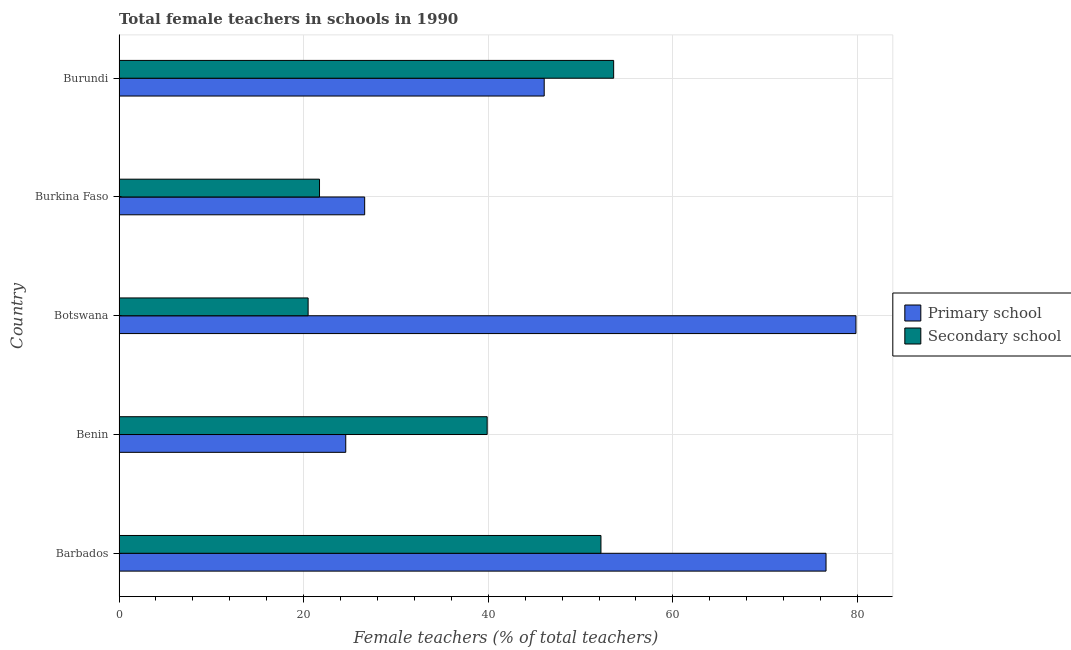How many different coloured bars are there?
Give a very brief answer. 2. How many groups of bars are there?
Your response must be concise. 5. Are the number of bars on each tick of the Y-axis equal?
Provide a succinct answer. Yes. What is the label of the 3rd group of bars from the top?
Ensure brevity in your answer.  Botswana. What is the percentage of female teachers in secondary schools in Burkina Faso?
Your answer should be very brief. 21.72. Across all countries, what is the maximum percentage of female teachers in secondary schools?
Keep it short and to the point. 53.58. Across all countries, what is the minimum percentage of female teachers in primary schools?
Offer a terse response. 24.56. In which country was the percentage of female teachers in primary schools maximum?
Offer a very short reply. Botswana. In which country was the percentage of female teachers in primary schools minimum?
Keep it short and to the point. Benin. What is the total percentage of female teachers in secondary schools in the graph?
Keep it short and to the point. 187.87. What is the difference between the percentage of female teachers in secondary schools in Benin and that in Burkina Faso?
Your response must be concise. 18.16. What is the difference between the percentage of female teachers in secondary schools in Burundi and the percentage of female teachers in primary schools in Barbados?
Your response must be concise. -23.01. What is the average percentage of female teachers in secondary schools per country?
Provide a short and direct response. 37.58. What is the difference between the percentage of female teachers in secondary schools and percentage of female teachers in primary schools in Benin?
Your answer should be compact. 15.32. In how many countries, is the percentage of female teachers in primary schools greater than 44 %?
Your answer should be compact. 3. Is the percentage of female teachers in secondary schools in Botswana less than that in Burkina Faso?
Provide a succinct answer. Yes. What is the difference between the highest and the second highest percentage of female teachers in primary schools?
Your response must be concise. 3.24. What is the difference between the highest and the lowest percentage of female teachers in secondary schools?
Provide a short and direct response. 33.1. In how many countries, is the percentage of female teachers in primary schools greater than the average percentage of female teachers in primary schools taken over all countries?
Offer a very short reply. 2. What does the 1st bar from the top in Burkina Faso represents?
Your answer should be very brief. Secondary school. What does the 1st bar from the bottom in Botswana represents?
Offer a terse response. Primary school. Are all the bars in the graph horizontal?
Ensure brevity in your answer.  Yes. How many countries are there in the graph?
Your response must be concise. 5. Are the values on the major ticks of X-axis written in scientific E-notation?
Make the answer very short. No. How are the legend labels stacked?
Offer a terse response. Vertical. What is the title of the graph?
Your answer should be compact. Total female teachers in schools in 1990. Does "Male labor force" appear as one of the legend labels in the graph?
Ensure brevity in your answer.  No. What is the label or title of the X-axis?
Your answer should be compact. Female teachers (% of total teachers). What is the Female teachers (% of total teachers) in Primary school in Barbados?
Keep it short and to the point. 76.59. What is the Female teachers (% of total teachers) of Secondary school in Barbados?
Offer a very short reply. 52.21. What is the Female teachers (% of total teachers) in Primary school in Benin?
Provide a short and direct response. 24.56. What is the Female teachers (% of total teachers) in Secondary school in Benin?
Keep it short and to the point. 39.88. What is the Female teachers (% of total teachers) in Primary school in Botswana?
Keep it short and to the point. 79.83. What is the Female teachers (% of total teachers) in Secondary school in Botswana?
Offer a very short reply. 20.48. What is the Female teachers (% of total teachers) in Primary school in Burkina Faso?
Keep it short and to the point. 26.61. What is the Female teachers (% of total teachers) of Secondary school in Burkina Faso?
Provide a short and direct response. 21.72. What is the Female teachers (% of total teachers) in Primary school in Burundi?
Keep it short and to the point. 46.06. What is the Female teachers (% of total teachers) of Secondary school in Burundi?
Make the answer very short. 53.58. Across all countries, what is the maximum Female teachers (% of total teachers) in Primary school?
Your response must be concise. 79.83. Across all countries, what is the maximum Female teachers (% of total teachers) of Secondary school?
Provide a succinct answer. 53.58. Across all countries, what is the minimum Female teachers (% of total teachers) in Primary school?
Provide a short and direct response. 24.56. Across all countries, what is the minimum Female teachers (% of total teachers) of Secondary school?
Make the answer very short. 20.48. What is the total Female teachers (% of total teachers) in Primary school in the graph?
Your answer should be compact. 253.66. What is the total Female teachers (% of total teachers) in Secondary school in the graph?
Ensure brevity in your answer.  187.87. What is the difference between the Female teachers (% of total teachers) in Primary school in Barbados and that in Benin?
Give a very brief answer. 52.03. What is the difference between the Female teachers (% of total teachers) in Secondary school in Barbados and that in Benin?
Offer a very short reply. 12.33. What is the difference between the Female teachers (% of total teachers) of Primary school in Barbados and that in Botswana?
Provide a succinct answer. -3.24. What is the difference between the Female teachers (% of total teachers) of Secondary school in Barbados and that in Botswana?
Your answer should be very brief. 31.72. What is the difference between the Female teachers (% of total teachers) of Primary school in Barbados and that in Burkina Faso?
Offer a terse response. 49.98. What is the difference between the Female teachers (% of total teachers) of Secondary school in Barbados and that in Burkina Faso?
Offer a terse response. 30.49. What is the difference between the Female teachers (% of total teachers) of Primary school in Barbados and that in Burundi?
Your answer should be compact. 30.53. What is the difference between the Female teachers (% of total teachers) in Secondary school in Barbados and that in Burundi?
Provide a succinct answer. -1.38. What is the difference between the Female teachers (% of total teachers) of Primary school in Benin and that in Botswana?
Ensure brevity in your answer.  -55.27. What is the difference between the Female teachers (% of total teachers) of Secondary school in Benin and that in Botswana?
Provide a short and direct response. 19.4. What is the difference between the Female teachers (% of total teachers) in Primary school in Benin and that in Burkina Faso?
Your response must be concise. -2.05. What is the difference between the Female teachers (% of total teachers) of Secondary school in Benin and that in Burkina Faso?
Your answer should be very brief. 18.16. What is the difference between the Female teachers (% of total teachers) in Primary school in Benin and that in Burundi?
Offer a very short reply. -21.5. What is the difference between the Female teachers (% of total teachers) in Secondary school in Benin and that in Burundi?
Keep it short and to the point. -13.7. What is the difference between the Female teachers (% of total teachers) in Primary school in Botswana and that in Burkina Faso?
Give a very brief answer. 53.22. What is the difference between the Female teachers (% of total teachers) in Secondary school in Botswana and that in Burkina Faso?
Give a very brief answer. -1.24. What is the difference between the Female teachers (% of total teachers) in Primary school in Botswana and that in Burundi?
Give a very brief answer. 33.77. What is the difference between the Female teachers (% of total teachers) of Secondary school in Botswana and that in Burundi?
Your response must be concise. -33.1. What is the difference between the Female teachers (% of total teachers) of Primary school in Burkina Faso and that in Burundi?
Provide a short and direct response. -19.45. What is the difference between the Female teachers (% of total teachers) in Secondary school in Burkina Faso and that in Burundi?
Your response must be concise. -31.87. What is the difference between the Female teachers (% of total teachers) in Primary school in Barbados and the Female teachers (% of total teachers) in Secondary school in Benin?
Make the answer very short. 36.71. What is the difference between the Female teachers (% of total teachers) in Primary school in Barbados and the Female teachers (% of total teachers) in Secondary school in Botswana?
Provide a short and direct response. 56.11. What is the difference between the Female teachers (% of total teachers) of Primary school in Barbados and the Female teachers (% of total teachers) of Secondary school in Burkina Faso?
Keep it short and to the point. 54.87. What is the difference between the Female teachers (% of total teachers) in Primary school in Barbados and the Female teachers (% of total teachers) in Secondary school in Burundi?
Your response must be concise. 23.01. What is the difference between the Female teachers (% of total teachers) in Primary school in Benin and the Female teachers (% of total teachers) in Secondary school in Botswana?
Your answer should be very brief. 4.08. What is the difference between the Female teachers (% of total teachers) of Primary school in Benin and the Female teachers (% of total teachers) of Secondary school in Burkina Faso?
Offer a very short reply. 2.84. What is the difference between the Female teachers (% of total teachers) of Primary school in Benin and the Female teachers (% of total teachers) of Secondary school in Burundi?
Give a very brief answer. -29.02. What is the difference between the Female teachers (% of total teachers) of Primary school in Botswana and the Female teachers (% of total teachers) of Secondary school in Burkina Faso?
Your response must be concise. 58.12. What is the difference between the Female teachers (% of total teachers) in Primary school in Botswana and the Female teachers (% of total teachers) in Secondary school in Burundi?
Make the answer very short. 26.25. What is the difference between the Female teachers (% of total teachers) in Primary school in Burkina Faso and the Female teachers (% of total teachers) in Secondary school in Burundi?
Make the answer very short. -26.97. What is the average Female teachers (% of total teachers) of Primary school per country?
Ensure brevity in your answer.  50.73. What is the average Female teachers (% of total teachers) in Secondary school per country?
Provide a succinct answer. 37.57. What is the difference between the Female teachers (% of total teachers) in Primary school and Female teachers (% of total teachers) in Secondary school in Barbados?
Your answer should be very brief. 24.38. What is the difference between the Female teachers (% of total teachers) in Primary school and Female teachers (% of total teachers) in Secondary school in Benin?
Your answer should be very brief. -15.32. What is the difference between the Female teachers (% of total teachers) in Primary school and Female teachers (% of total teachers) in Secondary school in Botswana?
Offer a terse response. 59.35. What is the difference between the Female teachers (% of total teachers) of Primary school and Female teachers (% of total teachers) of Secondary school in Burkina Faso?
Ensure brevity in your answer.  4.89. What is the difference between the Female teachers (% of total teachers) in Primary school and Female teachers (% of total teachers) in Secondary school in Burundi?
Make the answer very short. -7.52. What is the ratio of the Female teachers (% of total teachers) of Primary school in Barbados to that in Benin?
Offer a very short reply. 3.12. What is the ratio of the Female teachers (% of total teachers) in Secondary school in Barbados to that in Benin?
Provide a short and direct response. 1.31. What is the ratio of the Female teachers (% of total teachers) of Primary school in Barbados to that in Botswana?
Your answer should be compact. 0.96. What is the ratio of the Female teachers (% of total teachers) in Secondary school in Barbados to that in Botswana?
Your response must be concise. 2.55. What is the ratio of the Female teachers (% of total teachers) of Primary school in Barbados to that in Burkina Faso?
Ensure brevity in your answer.  2.88. What is the ratio of the Female teachers (% of total teachers) in Secondary school in Barbados to that in Burkina Faso?
Offer a very short reply. 2.4. What is the ratio of the Female teachers (% of total teachers) of Primary school in Barbados to that in Burundi?
Keep it short and to the point. 1.66. What is the ratio of the Female teachers (% of total teachers) of Secondary school in Barbados to that in Burundi?
Your response must be concise. 0.97. What is the ratio of the Female teachers (% of total teachers) of Primary school in Benin to that in Botswana?
Ensure brevity in your answer.  0.31. What is the ratio of the Female teachers (% of total teachers) in Secondary school in Benin to that in Botswana?
Offer a very short reply. 1.95. What is the ratio of the Female teachers (% of total teachers) in Primary school in Benin to that in Burkina Faso?
Give a very brief answer. 0.92. What is the ratio of the Female teachers (% of total teachers) in Secondary school in Benin to that in Burkina Faso?
Your response must be concise. 1.84. What is the ratio of the Female teachers (% of total teachers) of Primary school in Benin to that in Burundi?
Your answer should be very brief. 0.53. What is the ratio of the Female teachers (% of total teachers) in Secondary school in Benin to that in Burundi?
Give a very brief answer. 0.74. What is the ratio of the Female teachers (% of total teachers) in Primary school in Botswana to that in Burkina Faso?
Give a very brief answer. 3. What is the ratio of the Female teachers (% of total teachers) in Secondary school in Botswana to that in Burkina Faso?
Your response must be concise. 0.94. What is the ratio of the Female teachers (% of total teachers) of Primary school in Botswana to that in Burundi?
Ensure brevity in your answer.  1.73. What is the ratio of the Female teachers (% of total teachers) in Secondary school in Botswana to that in Burundi?
Ensure brevity in your answer.  0.38. What is the ratio of the Female teachers (% of total teachers) of Primary school in Burkina Faso to that in Burundi?
Offer a very short reply. 0.58. What is the ratio of the Female teachers (% of total teachers) of Secondary school in Burkina Faso to that in Burundi?
Ensure brevity in your answer.  0.41. What is the difference between the highest and the second highest Female teachers (% of total teachers) in Primary school?
Provide a succinct answer. 3.24. What is the difference between the highest and the second highest Female teachers (% of total teachers) in Secondary school?
Ensure brevity in your answer.  1.38. What is the difference between the highest and the lowest Female teachers (% of total teachers) of Primary school?
Ensure brevity in your answer.  55.27. What is the difference between the highest and the lowest Female teachers (% of total teachers) in Secondary school?
Provide a succinct answer. 33.1. 